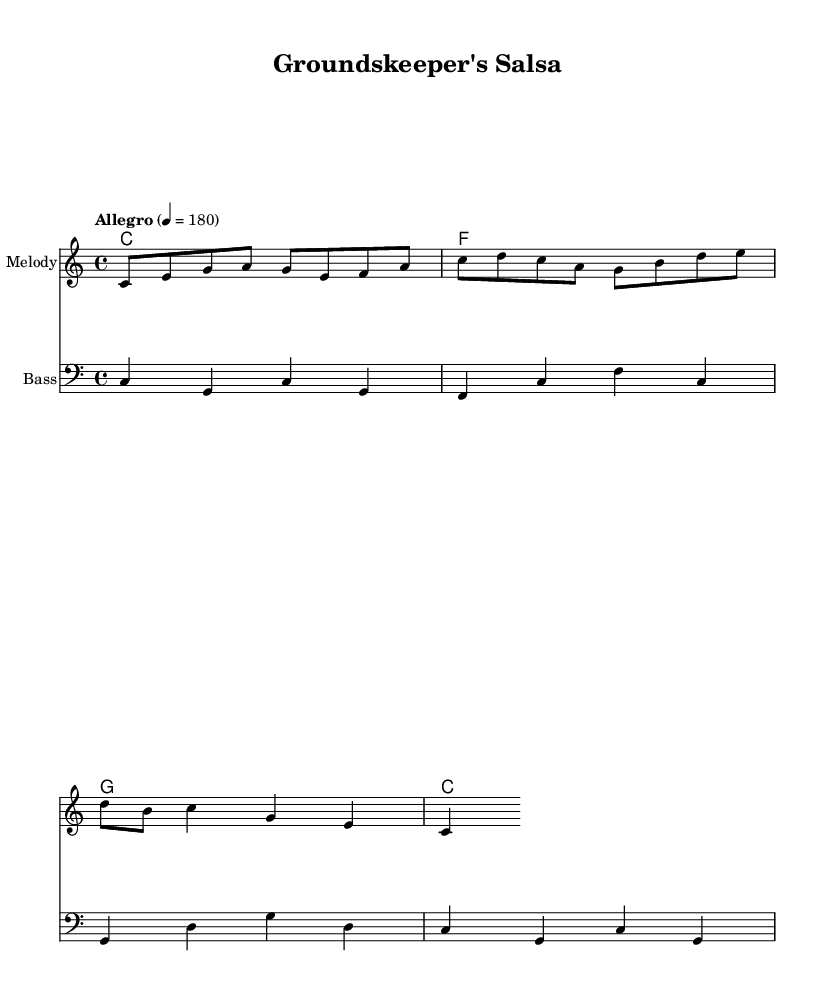What is the key signature of this music? The key signature is indicated by the section at the beginning of the staff, which shows no sharps or flats. This corresponds to C major.
Answer: C major What is the time signature of this music? The time signature appears at the start of the music, written as "4/4", indicating there are four beats in each measure and the quarter note gets one beat.
Answer: 4/4 What is the tempo marking in this music? The tempo marking is located above the staff and is written as "Allegro" with a metronome marking of "4 = 180", indicating a fast speed.
Answer: Allegro How many measures are in the melody? Counting the measures in the melody line, there are a total of four measures present.
Answer: Four What is the name of the piece? The title of the piece is indicated at the top of the sheet music as "Groundskeeper's Salsa."
Answer: Groundskeeper's Salsa What kind of music is this? The presence of lively rhythms, upbeat tempo, and lyrics celebrating nature and outdoor work suggests that this is salsa music.
Answer: Salsa Which instrument is indicated for the melody part? The instrumental part for the melody is specified in the score as "Melody," typically played by a lead instrument in salsa music.
Answer: Melody 